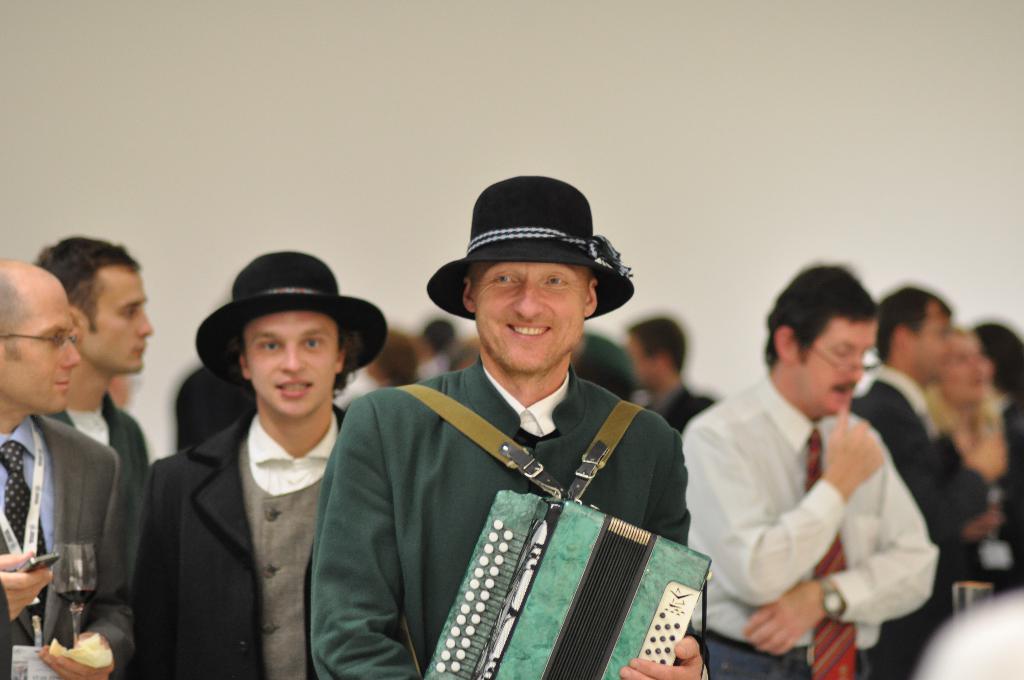Describe this image in one or two sentences. In this picture I can see there is a person standing at the center, he is wearing a cap and playing a musical cap. There is a person standing at left, holding the wine glass and there are a few more people in the backdrop and there is a white wall in the backdrop. 